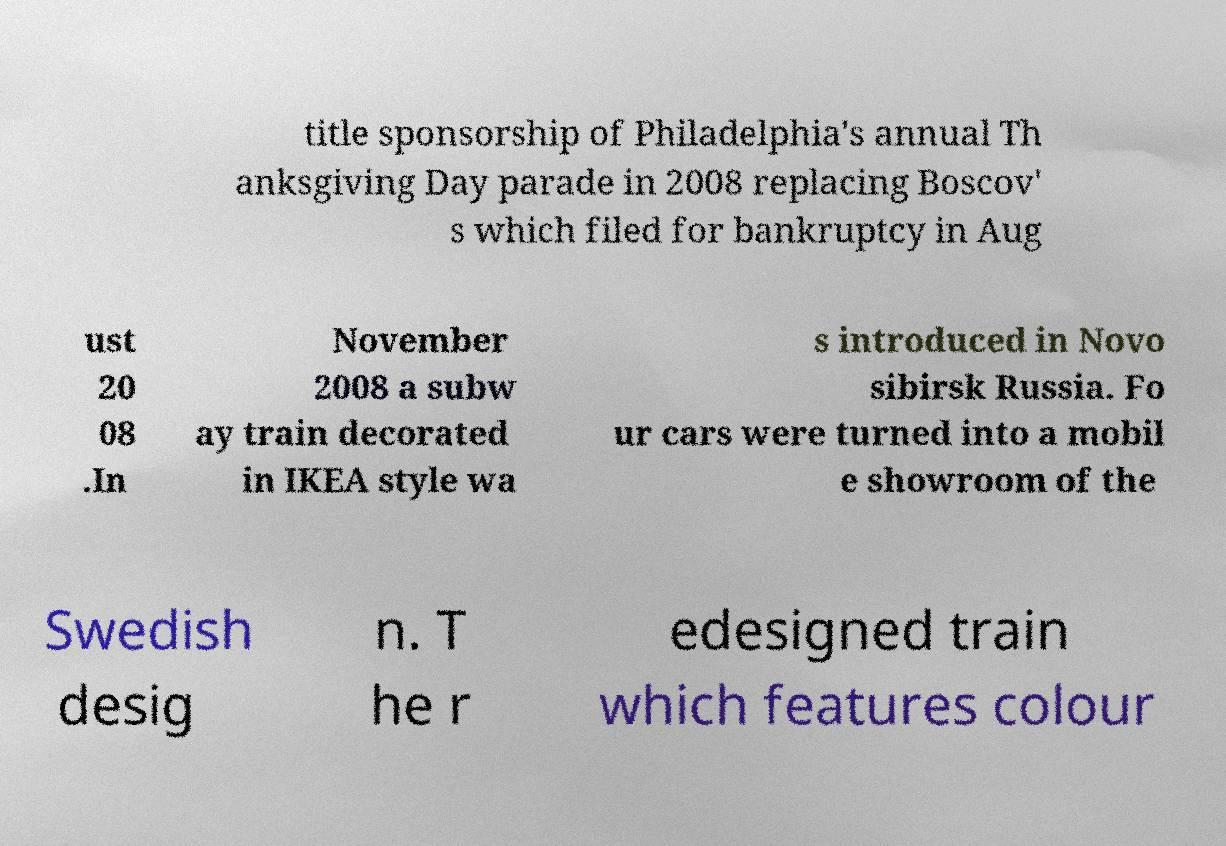Could you extract and type out the text from this image? title sponsorship of Philadelphia's annual Th anksgiving Day parade in 2008 replacing Boscov' s which filed for bankruptcy in Aug ust 20 08 .In November 2008 a subw ay train decorated in IKEA style wa s introduced in Novo sibirsk Russia. Fo ur cars were turned into a mobil e showroom of the Swedish desig n. T he r edesigned train which features colour 